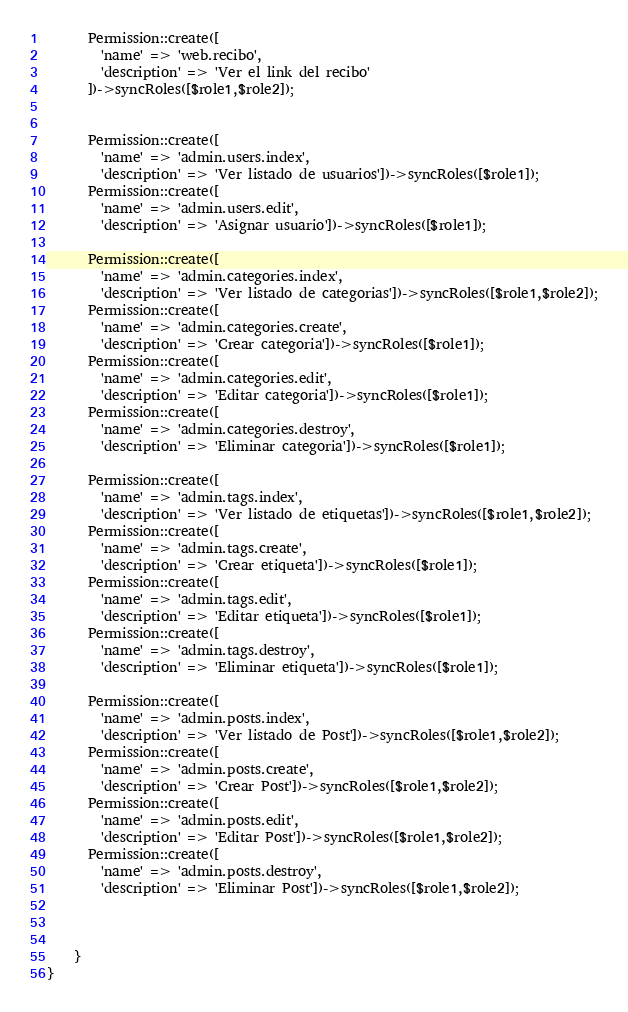<code> <loc_0><loc_0><loc_500><loc_500><_PHP_>      Permission::create([
        'name' => 'web.recibo',
        'description' => 'Ver el link del recibo'
      ])->syncRoles([$role1,$role2]);


      Permission::create([
        'name' => 'admin.users.index',
        'description' => 'Ver listado de usuarios'])->syncRoles([$role1]);
      Permission::create([
        'name' => 'admin.users.edit',
        'description' => 'Asignar usuario'])->syncRoles([$role1]);
    
      Permission::create([
        'name' => 'admin.categories.index',
        'description' => 'Ver listado de categorias'])->syncRoles([$role1,$role2]);
      Permission::create([
        'name' => 'admin.categories.create',
        'description' => 'Crear categoria'])->syncRoles([$role1]);
      Permission::create([
        'name' => 'admin.categories.edit',
        'description' => 'Editar categoria'])->syncRoles([$role1]);
      Permission::create([
        'name' => 'admin.categories.destroy',
        'description' => 'Eliminar categoria'])->syncRoles([$role1]);

      Permission::create([
        'name' => 'admin.tags.index',
        'description' => 'Ver listado de etiquetas'])->syncRoles([$role1,$role2]);
      Permission::create([
        'name' => 'admin.tags.create',
        'description' => 'Crear etiqueta'])->syncRoles([$role1]);
      Permission::create([
        'name' => 'admin.tags.edit',
        'description' => 'Editar etiqueta'])->syncRoles([$role1]);
      Permission::create([
        'name' => 'admin.tags.destroy',
        'description' => 'Eliminar etiqueta'])->syncRoles([$role1]);

      Permission::create([
        'name' => 'admin.posts.index',
        'description' => 'Ver listado de Post'])->syncRoles([$role1,$role2]);
      Permission::create([
        'name' => 'admin.posts.create',
        'description' => 'Crear Post'])->syncRoles([$role1,$role2]);
      Permission::create([
        'name' => 'admin.posts.edit',
        'description' => 'Editar Post'])->syncRoles([$role1,$role2]);
      Permission::create([
        'name' => 'admin.posts.destroy',
        'description' => 'Eliminar Post'])->syncRoles([$role1,$role2]);

     

    }
}
</code> 